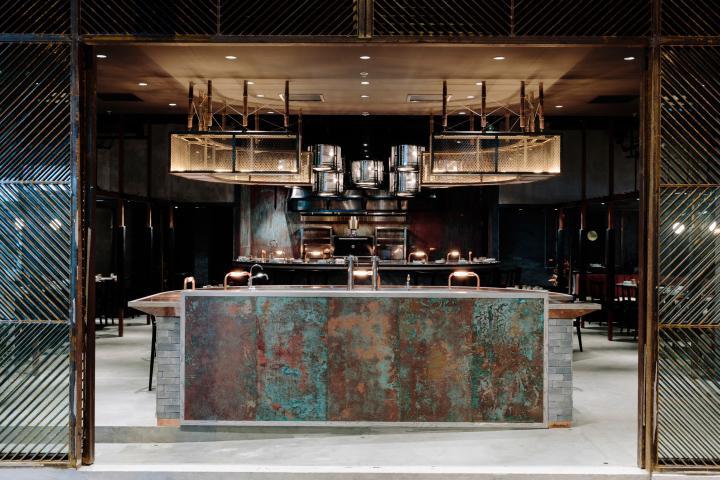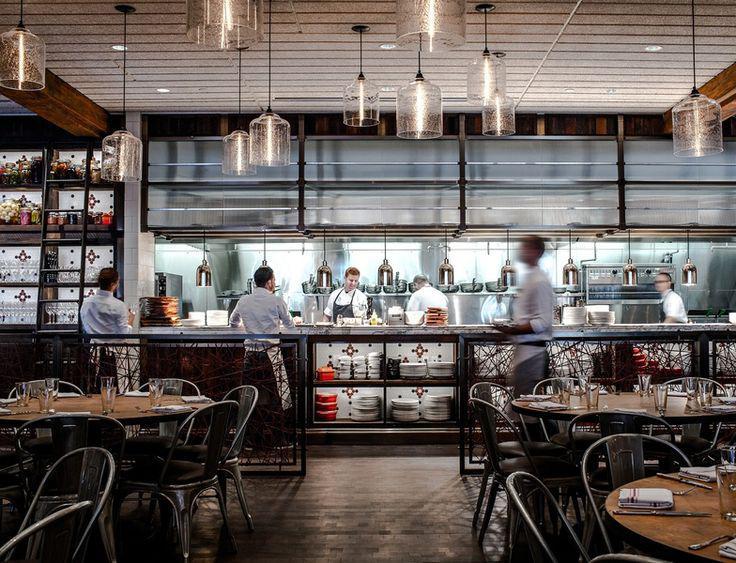The first image is the image on the left, the second image is the image on the right. For the images displayed, is the sentence "Each image contains restaurant employees" factually correct? Answer yes or no. No. The first image is the image on the left, the second image is the image on the right. Given the left and right images, does the statement "People in white shirts are in front of and behind the long counter of an establishment with suspended glass lights in one image." hold true? Answer yes or no. Yes. 